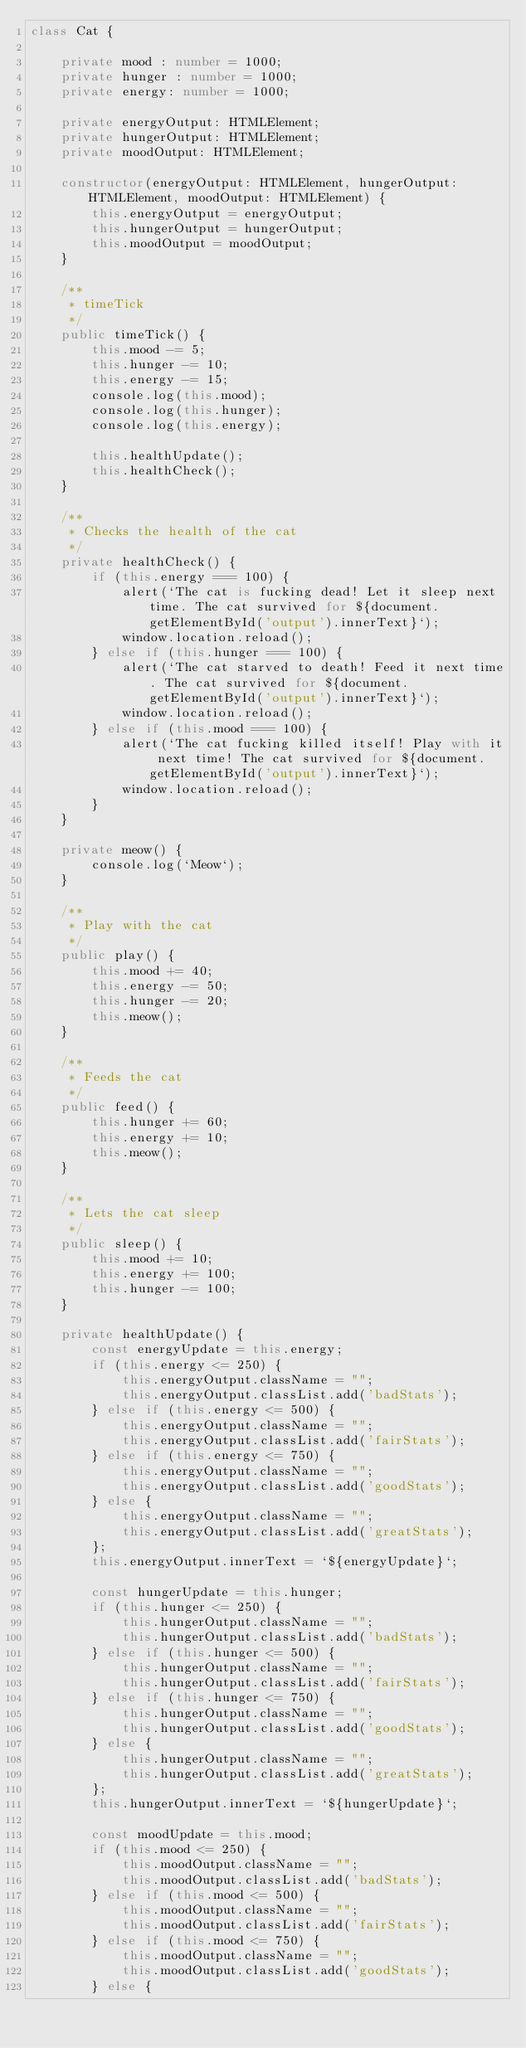<code> <loc_0><loc_0><loc_500><loc_500><_TypeScript_>class Cat {

    private mood : number = 1000;
    private hunger : number = 1000;
    private energy: number = 1000;

    private energyOutput: HTMLElement;
    private hungerOutput: HTMLElement;
    private moodOutput: HTMLElement;

    constructor(energyOutput: HTMLElement, hungerOutput: HTMLElement, moodOutput: HTMLElement) {
        this.energyOutput = energyOutput;
        this.hungerOutput = hungerOutput;
        this.moodOutput = moodOutput;
    }
    
    /**
     * timeTick
     */
    public timeTick() {
        this.mood -= 5;
        this.hunger -= 10;
        this.energy -= 15;
        console.log(this.mood);
        console.log(this.hunger);
        console.log(this.energy);
        
        this.healthUpdate();
        this.healthCheck();
    }

    /**
     * Checks the health of the cat
     */
    private healthCheck() {
        if (this.energy === 100) {
            alert(`The cat is fucking dead! Let it sleep next time. The cat survived for ${document.getElementById('output').innerText}`);
            window.location.reload();
        } else if (this.hunger === 100) {
            alert(`The cat starved to death! Feed it next time. The cat survived for ${document.getElementById('output').innerText}`);
            window.location.reload();
        } else if (this.mood === 100) {
            alert(`The cat fucking killed itself! Play with it next time! The cat survived for ${document.getElementById('output').innerText}`);
            window.location.reload();
        }
    }
    
    private meow() {
        console.log(`Meow`);
    }

    /**
     * Play with the cat
     */
    public play() {
        this.mood += 40;
        this.energy -= 50;
        this.hunger -= 20;
        this.meow();
    }

    /**
     * Feeds the cat
     */
    public feed() {
        this.hunger += 60;
        this.energy += 10;
        this.meow();
    }

    /**
     * Lets the cat sleep
     */
    public sleep() {
        this.mood += 10;
        this.energy += 100;
        this.hunger -= 100;
    }

    private healthUpdate() {
        const energyUpdate = this.energy;
        if (this.energy <= 250) {
            this.energyOutput.className = "";
            this.energyOutput.classList.add('badStats');
        } else if (this.energy <= 500) {
            this.energyOutput.className = "";
            this.energyOutput.classList.add('fairStats');
        } else if (this.energy <= 750) {
            this.energyOutput.className = "";
            this.energyOutput.classList.add('goodStats');
        } else {
            this.energyOutput.className = "";
            this.energyOutput.classList.add('greatStats');
        };
        this.energyOutput.innerText = `${energyUpdate}`;
        
        const hungerUpdate = this.hunger;
        if (this.hunger <= 250) {
            this.hungerOutput.className = "";
            this.hungerOutput.classList.add('badStats');
        } else if (this.hunger <= 500) {
            this.hungerOutput.className = "";
            this.hungerOutput.classList.add('fairStats');
        } else if (this.hunger <= 750) {
            this.hungerOutput.className = "";
            this.hungerOutput.classList.add('goodStats');
        } else {
            this.hungerOutput.className = "";
            this.hungerOutput.classList.add('greatStats');
        };
        this.hungerOutput.innerText = `${hungerUpdate}`;
        
        const moodUpdate = this.mood;
        if (this.mood <= 250) {
            this.moodOutput.className = "";
            this.moodOutput.classList.add('badStats');
        } else if (this.mood <= 500) {
            this.moodOutput.className = "";
            this.moodOutput.classList.add('fairStats');
        } else if (this.mood <= 750) {
            this.moodOutput.className = "";
            this.moodOutput.classList.add('goodStats');
        } else {</code> 